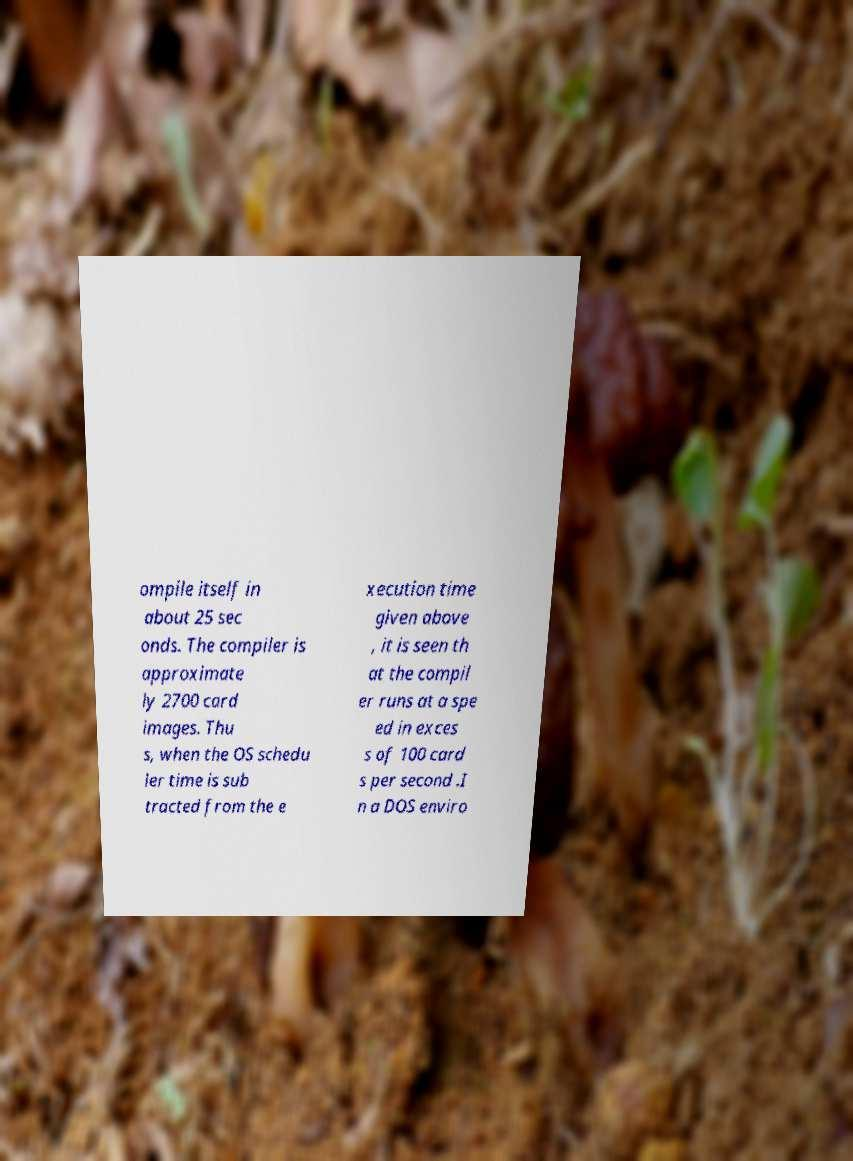Please identify and transcribe the text found in this image. ompile itself in about 25 sec onds. The compiler is approximate ly 2700 card images. Thu s, when the OS schedu ler time is sub tracted from the e xecution time given above , it is seen th at the compil er runs at a spe ed in exces s of 100 card s per second .I n a DOS enviro 